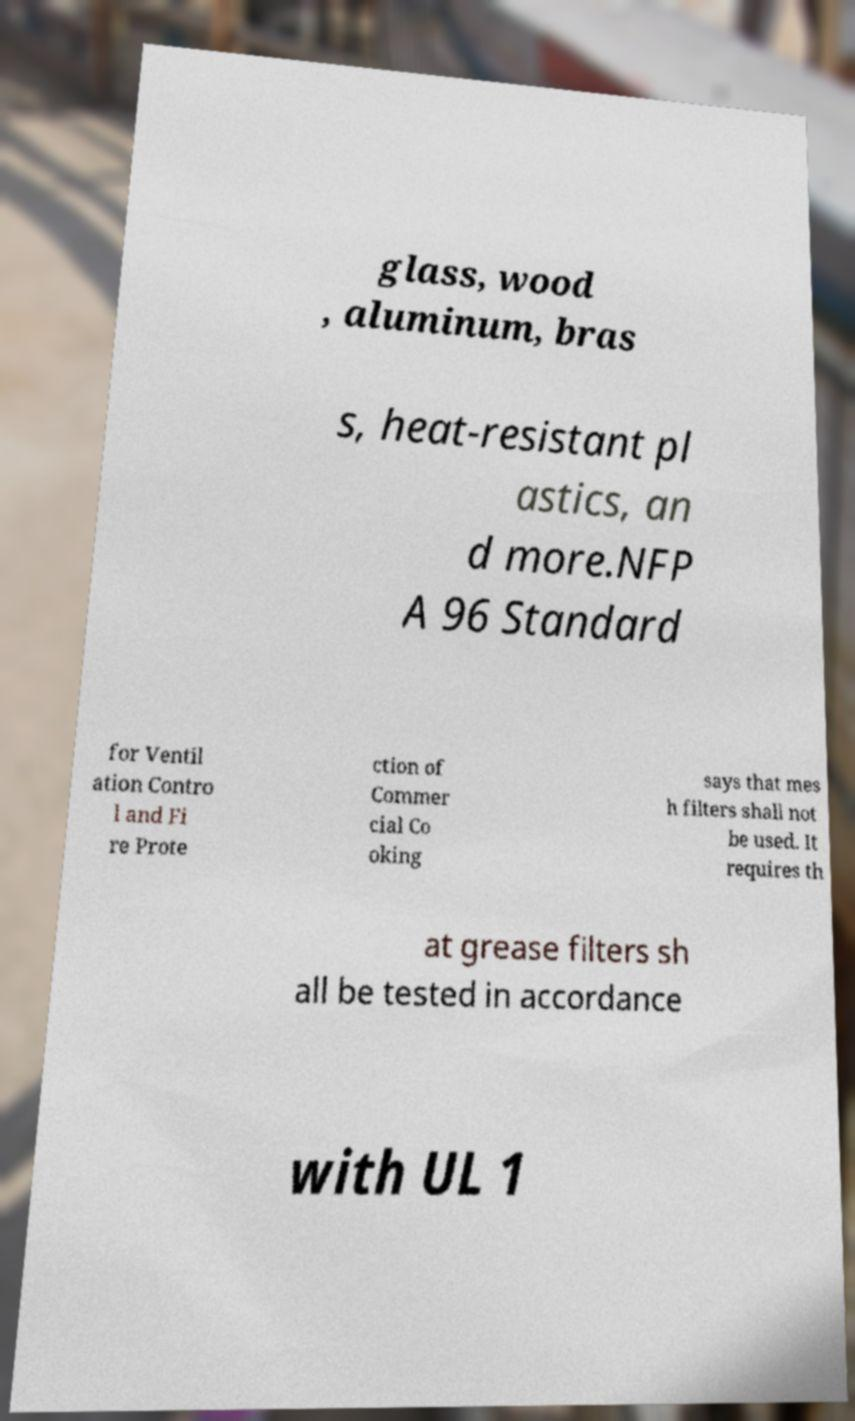Can you read and provide the text displayed in the image?This photo seems to have some interesting text. Can you extract and type it out for me? glass, wood , aluminum, bras s, heat-resistant pl astics, an d more.NFP A 96 Standard for Ventil ation Contro l and Fi re Prote ction of Commer cial Co oking says that mes h filters shall not be used. It requires th at grease filters sh all be tested in accordance with UL 1 